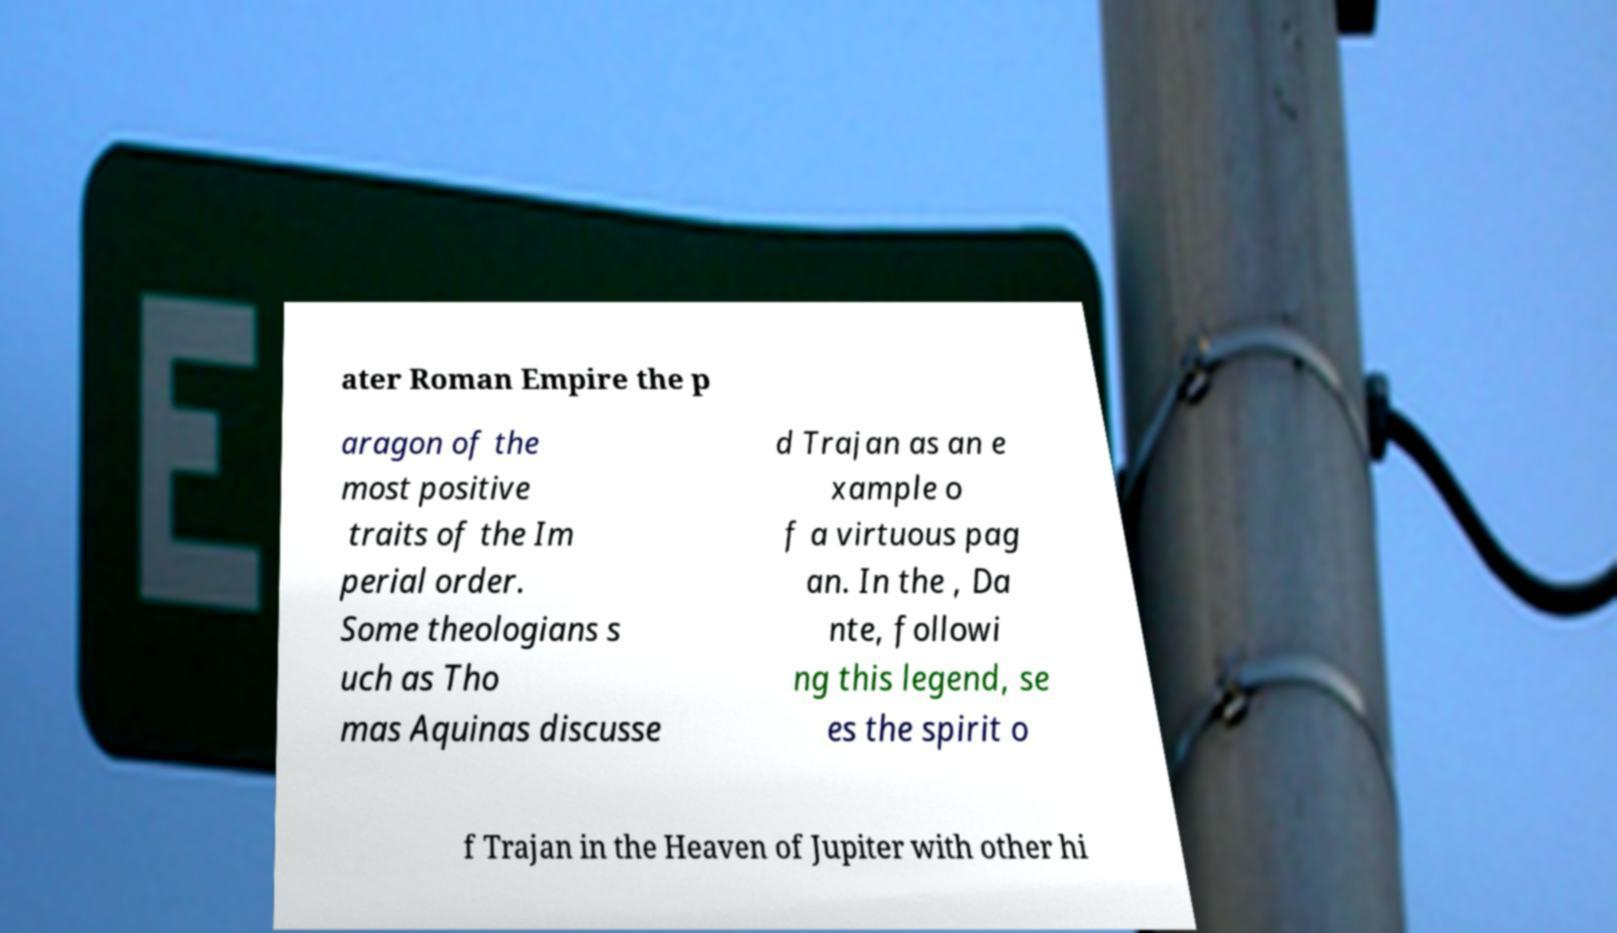Could you extract and type out the text from this image? ater Roman Empire the p aragon of the most positive traits of the Im perial order. Some theologians s uch as Tho mas Aquinas discusse d Trajan as an e xample o f a virtuous pag an. In the , Da nte, followi ng this legend, se es the spirit o f Trajan in the Heaven of Jupiter with other hi 